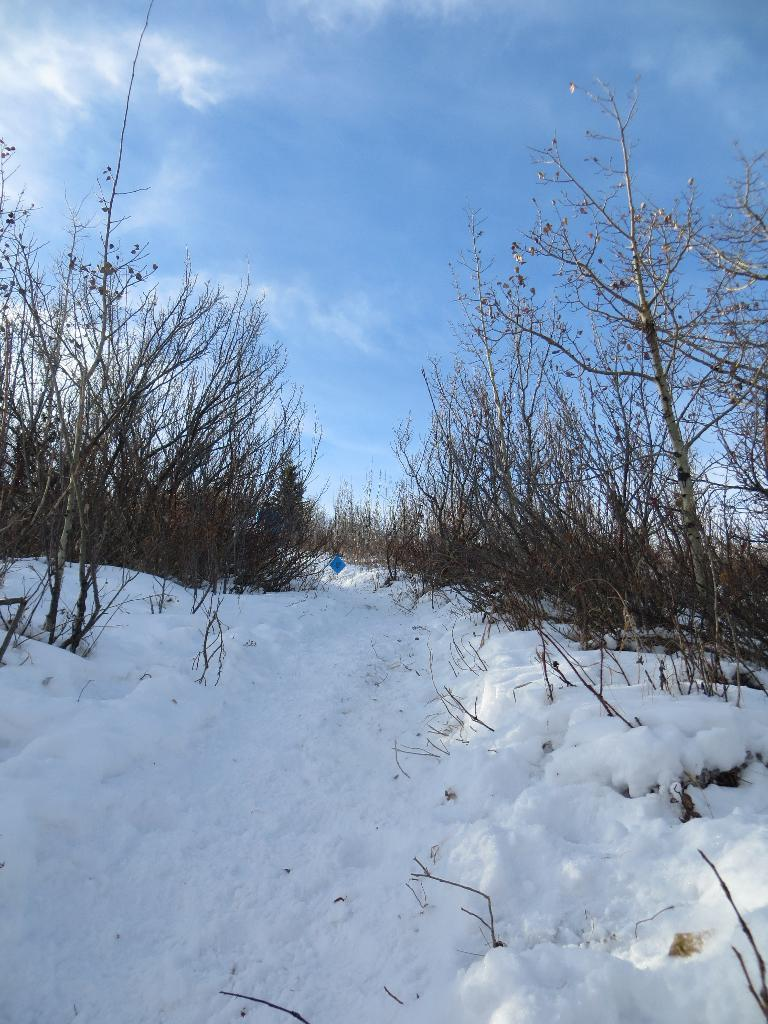What is covering the ground at the bottom of the image? There is snow on the ground at the bottom of the image. What can be observed about the plants in the image? The plants in the image do not have leaves. What part of the natural environment is visible in the background of the image? The sky is visible in the background of the image. How many women are talking to each other in the image? There are no women present in the image, nor is there any indication of conversation. 